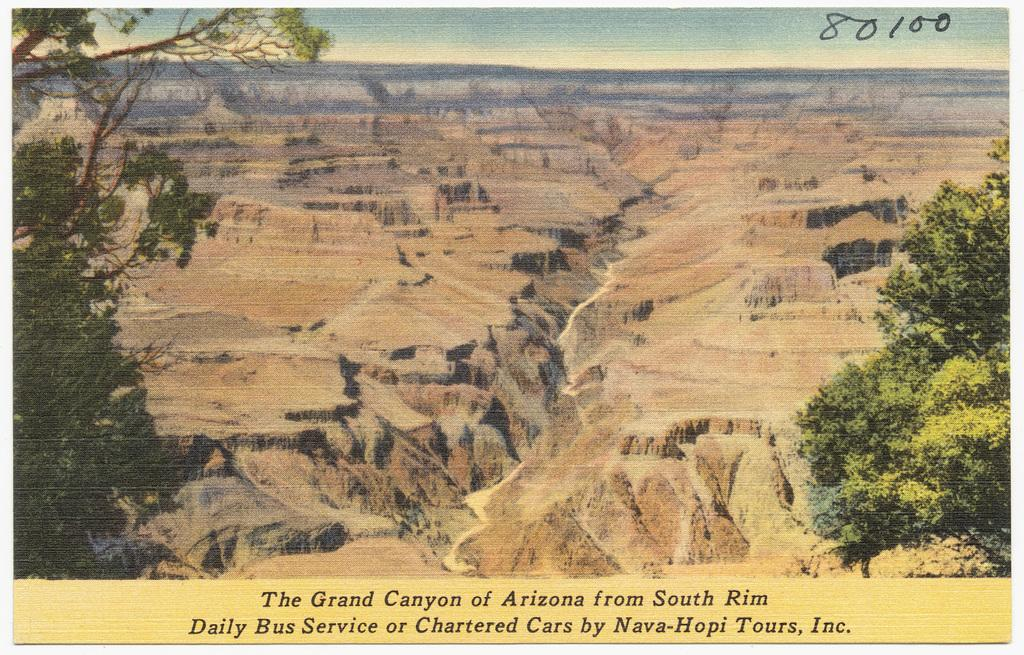What type of natural elements are present in the painting? The painting contains trees and mountains. Are there any man-made elements in the painting? Yes, there is text present in the painting. What can be seen in the sky in the painting? The sky is visible in the painting. Can you see any potatoes growing near the seashore in the painting? There is no seashore or potatoes depicted in the painting; it features trees, mountains, and text. 